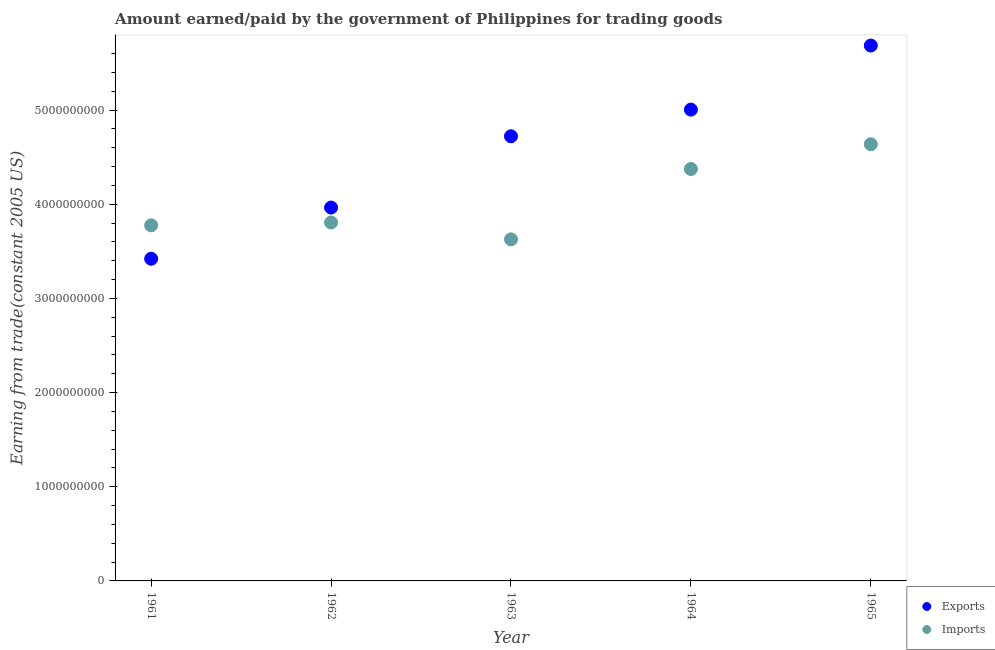What is the amount earned from exports in 1962?
Your response must be concise. 3.97e+09. Across all years, what is the maximum amount paid for imports?
Provide a succinct answer. 4.64e+09. Across all years, what is the minimum amount earned from exports?
Ensure brevity in your answer.  3.42e+09. In which year was the amount paid for imports maximum?
Make the answer very short. 1965. In which year was the amount paid for imports minimum?
Ensure brevity in your answer.  1963. What is the total amount earned from exports in the graph?
Ensure brevity in your answer.  2.28e+1. What is the difference between the amount earned from exports in 1961 and that in 1963?
Make the answer very short. -1.30e+09. What is the difference between the amount paid for imports in 1963 and the amount earned from exports in 1965?
Provide a short and direct response. -2.06e+09. What is the average amount paid for imports per year?
Offer a terse response. 4.04e+09. In the year 1964, what is the difference between the amount earned from exports and amount paid for imports?
Your answer should be compact. 6.31e+08. In how many years, is the amount earned from exports greater than 5000000000 US$?
Your response must be concise. 2. What is the ratio of the amount earned from exports in 1962 to that in 1963?
Ensure brevity in your answer.  0.84. Is the amount earned from exports in 1963 less than that in 1964?
Your answer should be very brief. Yes. Is the difference between the amount earned from exports in 1961 and 1964 greater than the difference between the amount paid for imports in 1961 and 1964?
Offer a terse response. No. What is the difference between the highest and the second highest amount earned from exports?
Your answer should be very brief. 6.80e+08. What is the difference between the highest and the lowest amount earned from exports?
Your response must be concise. 2.26e+09. In how many years, is the amount paid for imports greater than the average amount paid for imports taken over all years?
Offer a very short reply. 2. Does the amount paid for imports monotonically increase over the years?
Make the answer very short. No. Is the amount earned from exports strictly greater than the amount paid for imports over the years?
Keep it short and to the point. No. Is the amount paid for imports strictly less than the amount earned from exports over the years?
Your answer should be compact. No. How many dotlines are there?
Make the answer very short. 2. How many years are there in the graph?
Offer a terse response. 5. What is the difference between two consecutive major ticks on the Y-axis?
Offer a very short reply. 1.00e+09. Are the values on the major ticks of Y-axis written in scientific E-notation?
Provide a short and direct response. No. Does the graph contain grids?
Provide a short and direct response. No. Where does the legend appear in the graph?
Give a very brief answer. Bottom right. How many legend labels are there?
Provide a succinct answer. 2. What is the title of the graph?
Provide a succinct answer. Amount earned/paid by the government of Philippines for trading goods. What is the label or title of the Y-axis?
Your answer should be compact. Earning from trade(constant 2005 US). What is the Earning from trade(constant 2005 US) of Exports in 1961?
Ensure brevity in your answer.  3.42e+09. What is the Earning from trade(constant 2005 US) of Imports in 1961?
Offer a very short reply. 3.78e+09. What is the Earning from trade(constant 2005 US) in Exports in 1962?
Provide a succinct answer. 3.97e+09. What is the Earning from trade(constant 2005 US) of Imports in 1962?
Ensure brevity in your answer.  3.81e+09. What is the Earning from trade(constant 2005 US) of Exports in 1963?
Offer a very short reply. 4.72e+09. What is the Earning from trade(constant 2005 US) of Imports in 1963?
Your answer should be very brief. 3.63e+09. What is the Earning from trade(constant 2005 US) of Exports in 1964?
Make the answer very short. 5.01e+09. What is the Earning from trade(constant 2005 US) of Imports in 1964?
Ensure brevity in your answer.  4.37e+09. What is the Earning from trade(constant 2005 US) in Exports in 1965?
Your answer should be compact. 5.69e+09. What is the Earning from trade(constant 2005 US) in Imports in 1965?
Provide a succinct answer. 4.64e+09. Across all years, what is the maximum Earning from trade(constant 2005 US) in Exports?
Provide a succinct answer. 5.69e+09. Across all years, what is the maximum Earning from trade(constant 2005 US) of Imports?
Provide a succinct answer. 4.64e+09. Across all years, what is the minimum Earning from trade(constant 2005 US) in Exports?
Your answer should be very brief. 3.42e+09. Across all years, what is the minimum Earning from trade(constant 2005 US) in Imports?
Offer a terse response. 3.63e+09. What is the total Earning from trade(constant 2005 US) in Exports in the graph?
Your answer should be compact. 2.28e+1. What is the total Earning from trade(constant 2005 US) of Imports in the graph?
Keep it short and to the point. 2.02e+1. What is the difference between the Earning from trade(constant 2005 US) in Exports in 1961 and that in 1962?
Keep it short and to the point. -5.44e+08. What is the difference between the Earning from trade(constant 2005 US) of Imports in 1961 and that in 1962?
Provide a short and direct response. -3.02e+07. What is the difference between the Earning from trade(constant 2005 US) in Exports in 1961 and that in 1963?
Your answer should be very brief. -1.30e+09. What is the difference between the Earning from trade(constant 2005 US) in Imports in 1961 and that in 1963?
Keep it short and to the point. 1.49e+08. What is the difference between the Earning from trade(constant 2005 US) in Exports in 1961 and that in 1964?
Your answer should be compact. -1.58e+09. What is the difference between the Earning from trade(constant 2005 US) of Imports in 1961 and that in 1964?
Offer a terse response. -5.98e+08. What is the difference between the Earning from trade(constant 2005 US) of Exports in 1961 and that in 1965?
Ensure brevity in your answer.  -2.26e+09. What is the difference between the Earning from trade(constant 2005 US) of Imports in 1961 and that in 1965?
Your answer should be very brief. -8.61e+08. What is the difference between the Earning from trade(constant 2005 US) of Exports in 1962 and that in 1963?
Your answer should be very brief. -7.57e+08. What is the difference between the Earning from trade(constant 2005 US) in Imports in 1962 and that in 1963?
Provide a succinct answer. 1.79e+08. What is the difference between the Earning from trade(constant 2005 US) in Exports in 1962 and that in 1964?
Make the answer very short. -1.04e+09. What is the difference between the Earning from trade(constant 2005 US) of Imports in 1962 and that in 1964?
Offer a terse response. -5.68e+08. What is the difference between the Earning from trade(constant 2005 US) in Exports in 1962 and that in 1965?
Keep it short and to the point. -1.72e+09. What is the difference between the Earning from trade(constant 2005 US) in Imports in 1962 and that in 1965?
Your answer should be compact. -8.31e+08. What is the difference between the Earning from trade(constant 2005 US) in Exports in 1963 and that in 1964?
Give a very brief answer. -2.83e+08. What is the difference between the Earning from trade(constant 2005 US) of Imports in 1963 and that in 1964?
Keep it short and to the point. -7.47e+08. What is the difference between the Earning from trade(constant 2005 US) of Exports in 1963 and that in 1965?
Your answer should be very brief. -9.64e+08. What is the difference between the Earning from trade(constant 2005 US) in Imports in 1963 and that in 1965?
Your answer should be compact. -1.01e+09. What is the difference between the Earning from trade(constant 2005 US) of Exports in 1964 and that in 1965?
Offer a terse response. -6.80e+08. What is the difference between the Earning from trade(constant 2005 US) in Imports in 1964 and that in 1965?
Provide a succinct answer. -2.63e+08. What is the difference between the Earning from trade(constant 2005 US) of Exports in 1961 and the Earning from trade(constant 2005 US) of Imports in 1962?
Give a very brief answer. -3.85e+08. What is the difference between the Earning from trade(constant 2005 US) in Exports in 1961 and the Earning from trade(constant 2005 US) in Imports in 1963?
Your answer should be compact. -2.06e+08. What is the difference between the Earning from trade(constant 2005 US) of Exports in 1961 and the Earning from trade(constant 2005 US) of Imports in 1964?
Make the answer very short. -9.53e+08. What is the difference between the Earning from trade(constant 2005 US) of Exports in 1961 and the Earning from trade(constant 2005 US) of Imports in 1965?
Provide a short and direct response. -1.22e+09. What is the difference between the Earning from trade(constant 2005 US) in Exports in 1962 and the Earning from trade(constant 2005 US) in Imports in 1963?
Ensure brevity in your answer.  3.38e+08. What is the difference between the Earning from trade(constant 2005 US) in Exports in 1962 and the Earning from trade(constant 2005 US) in Imports in 1964?
Offer a terse response. -4.10e+08. What is the difference between the Earning from trade(constant 2005 US) in Exports in 1962 and the Earning from trade(constant 2005 US) in Imports in 1965?
Make the answer very short. -6.72e+08. What is the difference between the Earning from trade(constant 2005 US) of Exports in 1963 and the Earning from trade(constant 2005 US) of Imports in 1964?
Offer a terse response. 3.47e+08. What is the difference between the Earning from trade(constant 2005 US) in Exports in 1963 and the Earning from trade(constant 2005 US) in Imports in 1965?
Make the answer very short. 8.46e+07. What is the difference between the Earning from trade(constant 2005 US) in Exports in 1964 and the Earning from trade(constant 2005 US) in Imports in 1965?
Give a very brief answer. 3.68e+08. What is the average Earning from trade(constant 2005 US) in Exports per year?
Provide a succinct answer. 4.56e+09. What is the average Earning from trade(constant 2005 US) in Imports per year?
Make the answer very short. 4.04e+09. In the year 1961, what is the difference between the Earning from trade(constant 2005 US) of Exports and Earning from trade(constant 2005 US) of Imports?
Offer a terse response. -3.55e+08. In the year 1962, what is the difference between the Earning from trade(constant 2005 US) in Exports and Earning from trade(constant 2005 US) in Imports?
Give a very brief answer. 1.59e+08. In the year 1963, what is the difference between the Earning from trade(constant 2005 US) in Exports and Earning from trade(constant 2005 US) in Imports?
Provide a short and direct response. 1.09e+09. In the year 1964, what is the difference between the Earning from trade(constant 2005 US) in Exports and Earning from trade(constant 2005 US) in Imports?
Offer a very short reply. 6.31e+08. In the year 1965, what is the difference between the Earning from trade(constant 2005 US) of Exports and Earning from trade(constant 2005 US) of Imports?
Offer a terse response. 1.05e+09. What is the ratio of the Earning from trade(constant 2005 US) of Exports in 1961 to that in 1962?
Provide a short and direct response. 0.86. What is the ratio of the Earning from trade(constant 2005 US) in Imports in 1961 to that in 1962?
Keep it short and to the point. 0.99. What is the ratio of the Earning from trade(constant 2005 US) of Exports in 1961 to that in 1963?
Give a very brief answer. 0.72. What is the ratio of the Earning from trade(constant 2005 US) of Imports in 1961 to that in 1963?
Your answer should be compact. 1.04. What is the ratio of the Earning from trade(constant 2005 US) of Exports in 1961 to that in 1964?
Your answer should be compact. 0.68. What is the ratio of the Earning from trade(constant 2005 US) of Imports in 1961 to that in 1964?
Offer a terse response. 0.86. What is the ratio of the Earning from trade(constant 2005 US) of Exports in 1961 to that in 1965?
Provide a short and direct response. 0.6. What is the ratio of the Earning from trade(constant 2005 US) in Imports in 1961 to that in 1965?
Provide a short and direct response. 0.81. What is the ratio of the Earning from trade(constant 2005 US) of Exports in 1962 to that in 1963?
Make the answer very short. 0.84. What is the ratio of the Earning from trade(constant 2005 US) in Imports in 1962 to that in 1963?
Your answer should be very brief. 1.05. What is the ratio of the Earning from trade(constant 2005 US) of Exports in 1962 to that in 1964?
Your answer should be very brief. 0.79. What is the ratio of the Earning from trade(constant 2005 US) of Imports in 1962 to that in 1964?
Keep it short and to the point. 0.87. What is the ratio of the Earning from trade(constant 2005 US) of Exports in 1962 to that in 1965?
Your answer should be compact. 0.7. What is the ratio of the Earning from trade(constant 2005 US) in Imports in 1962 to that in 1965?
Offer a terse response. 0.82. What is the ratio of the Earning from trade(constant 2005 US) in Exports in 1963 to that in 1964?
Provide a succinct answer. 0.94. What is the ratio of the Earning from trade(constant 2005 US) of Imports in 1963 to that in 1964?
Your answer should be compact. 0.83. What is the ratio of the Earning from trade(constant 2005 US) of Exports in 1963 to that in 1965?
Your answer should be compact. 0.83. What is the ratio of the Earning from trade(constant 2005 US) in Imports in 1963 to that in 1965?
Offer a terse response. 0.78. What is the ratio of the Earning from trade(constant 2005 US) of Exports in 1964 to that in 1965?
Your answer should be compact. 0.88. What is the ratio of the Earning from trade(constant 2005 US) of Imports in 1964 to that in 1965?
Offer a very short reply. 0.94. What is the difference between the highest and the second highest Earning from trade(constant 2005 US) of Exports?
Provide a succinct answer. 6.80e+08. What is the difference between the highest and the second highest Earning from trade(constant 2005 US) in Imports?
Give a very brief answer. 2.63e+08. What is the difference between the highest and the lowest Earning from trade(constant 2005 US) of Exports?
Your answer should be very brief. 2.26e+09. What is the difference between the highest and the lowest Earning from trade(constant 2005 US) in Imports?
Your answer should be very brief. 1.01e+09. 